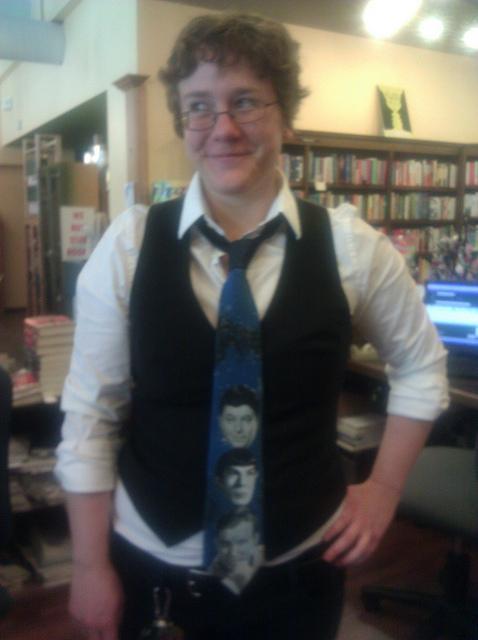How many people are in the photo?
Give a very brief answer. 1. 